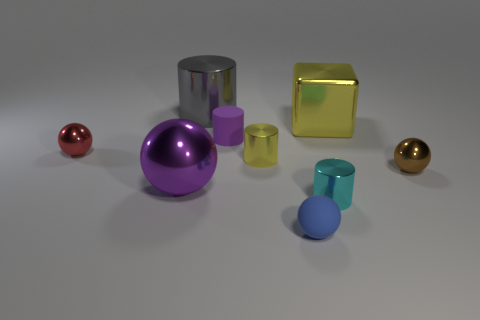Are there any patterns or designs on the objects? No, the objects are uniformly colored without any additional patterns or designs. Their surfaces are smooth and feature a single color each. How is the lighting affecting the appearance of these objects? The lighting creates soft shadows and subtle highlights on the objects, enhancing their three-dimensional form and texture. Reflective objects such as the spheres and glossy cylinders display more pronounced highlights and reflections. 